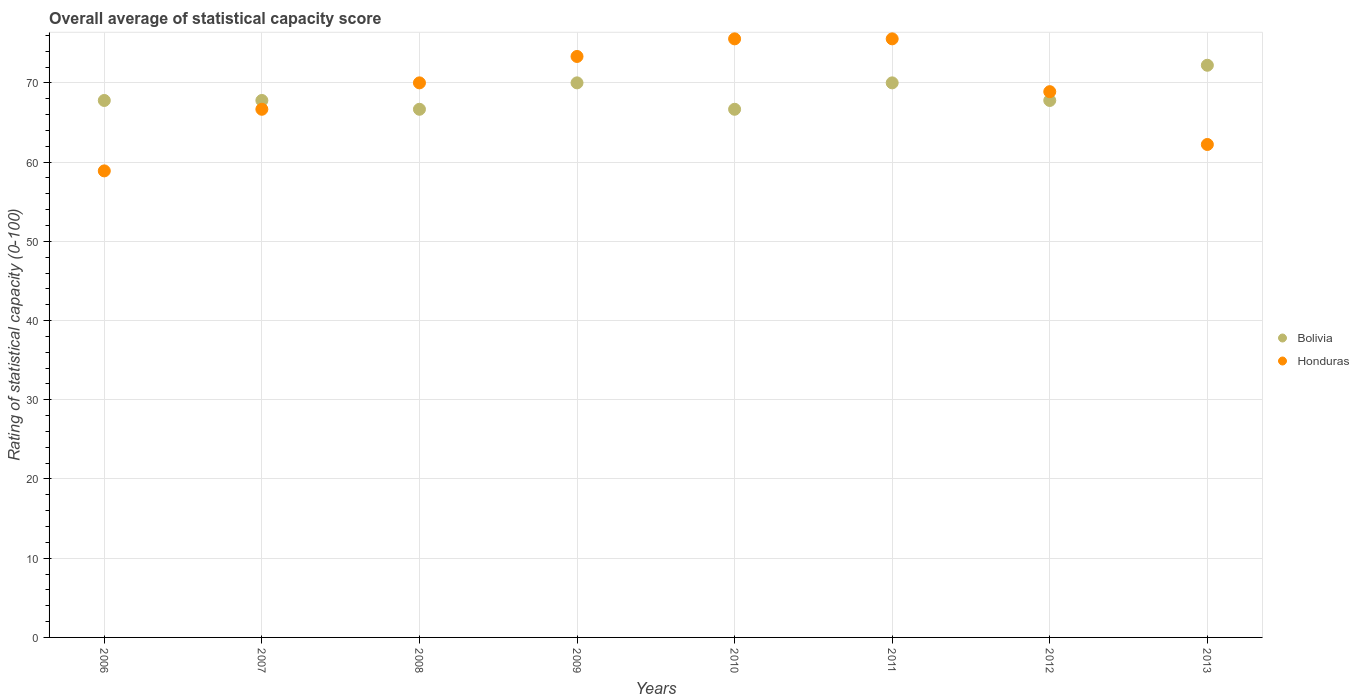How many different coloured dotlines are there?
Make the answer very short. 2. What is the rating of statistical capacity in Bolivia in 2012?
Your answer should be compact. 67.78. Across all years, what is the maximum rating of statistical capacity in Honduras?
Your response must be concise. 75.56. Across all years, what is the minimum rating of statistical capacity in Bolivia?
Make the answer very short. 66.67. What is the total rating of statistical capacity in Bolivia in the graph?
Provide a short and direct response. 548.89. What is the difference between the rating of statistical capacity in Bolivia in 2006 and that in 2010?
Offer a terse response. 1.11. What is the difference between the rating of statistical capacity in Honduras in 2006 and the rating of statistical capacity in Bolivia in 2013?
Your response must be concise. -13.33. What is the average rating of statistical capacity in Honduras per year?
Offer a terse response. 68.89. In the year 2011, what is the difference between the rating of statistical capacity in Bolivia and rating of statistical capacity in Honduras?
Keep it short and to the point. -5.56. In how many years, is the rating of statistical capacity in Bolivia greater than 34?
Give a very brief answer. 8. What is the ratio of the rating of statistical capacity in Bolivia in 2007 to that in 2010?
Your answer should be very brief. 1.02. Is the rating of statistical capacity in Honduras in 2010 less than that in 2013?
Ensure brevity in your answer.  No. What is the difference between the highest and the lowest rating of statistical capacity in Honduras?
Offer a very short reply. 16.67. Is the sum of the rating of statistical capacity in Bolivia in 2008 and 2013 greater than the maximum rating of statistical capacity in Honduras across all years?
Give a very brief answer. Yes. Does the rating of statistical capacity in Bolivia monotonically increase over the years?
Provide a succinct answer. No. Is the rating of statistical capacity in Bolivia strictly greater than the rating of statistical capacity in Honduras over the years?
Provide a succinct answer. No. What is the difference between two consecutive major ticks on the Y-axis?
Your answer should be compact. 10. How are the legend labels stacked?
Provide a succinct answer. Vertical. What is the title of the graph?
Give a very brief answer. Overall average of statistical capacity score. Does "Myanmar" appear as one of the legend labels in the graph?
Your answer should be very brief. No. What is the label or title of the Y-axis?
Your response must be concise. Rating of statistical capacity (0-100). What is the Rating of statistical capacity (0-100) in Bolivia in 2006?
Your answer should be compact. 67.78. What is the Rating of statistical capacity (0-100) in Honduras in 2006?
Give a very brief answer. 58.89. What is the Rating of statistical capacity (0-100) of Bolivia in 2007?
Provide a succinct answer. 67.78. What is the Rating of statistical capacity (0-100) in Honduras in 2007?
Provide a succinct answer. 66.67. What is the Rating of statistical capacity (0-100) in Bolivia in 2008?
Your response must be concise. 66.67. What is the Rating of statistical capacity (0-100) in Honduras in 2008?
Make the answer very short. 70. What is the Rating of statistical capacity (0-100) of Bolivia in 2009?
Ensure brevity in your answer.  70. What is the Rating of statistical capacity (0-100) of Honduras in 2009?
Keep it short and to the point. 73.33. What is the Rating of statistical capacity (0-100) in Bolivia in 2010?
Your answer should be very brief. 66.67. What is the Rating of statistical capacity (0-100) of Honduras in 2010?
Your response must be concise. 75.56. What is the Rating of statistical capacity (0-100) of Bolivia in 2011?
Keep it short and to the point. 70. What is the Rating of statistical capacity (0-100) of Honduras in 2011?
Your answer should be very brief. 75.56. What is the Rating of statistical capacity (0-100) in Bolivia in 2012?
Keep it short and to the point. 67.78. What is the Rating of statistical capacity (0-100) in Honduras in 2012?
Offer a very short reply. 68.89. What is the Rating of statistical capacity (0-100) of Bolivia in 2013?
Offer a very short reply. 72.22. What is the Rating of statistical capacity (0-100) in Honduras in 2013?
Ensure brevity in your answer.  62.22. Across all years, what is the maximum Rating of statistical capacity (0-100) in Bolivia?
Provide a succinct answer. 72.22. Across all years, what is the maximum Rating of statistical capacity (0-100) in Honduras?
Provide a short and direct response. 75.56. Across all years, what is the minimum Rating of statistical capacity (0-100) in Bolivia?
Ensure brevity in your answer.  66.67. Across all years, what is the minimum Rating of statistical capacity (0-100) in Honduras?
Offer a very short reply. 58.89. What is the total Rating of statistical capacity (0-100) of Bolivia in the graph?
Ensure brevity in your answer.  548.89. What is the total Rating of statistical capacity (0-100) of Honduras in the graph?
Offer a very short reply. 551.11. What is the difference between the Rating of statistical capacity (0-100) in Bolivia in 2006 and that in 2007?
Offer a terse response. 0. What is the difference between the Rating of statistical capacity (0-100) in Honduras in 2006 and that in 2007?
Offer a terse response. -7.78. What is the difference between the Rating of statistical capacity (0-100) of Bolivia in 2006 and that in 2008?
Your answer should be compact. 1.11. What is the difference between the Rating of statistical capacity (0-100) in Honduras in 2006 and that in 2008?
Provide a short and direct response. -11.11. What is the difference between the Rating of statistical capacity (0-100) in Bolivia in 2006 and that in 2009?
Give a very brief answer. -2.22. What is the difference between the Rating of statistical capacity (0-100) in Honduras in 2006 and that in 2009?
Your answer should be compact. -14.44. What is the difference between the Rating of statistical capacity (0-100) of Bolivia in 2006 and that in 2010?
Provide a succinct answer. 1.11. What is the difference between the Rating of statistical capacity (0-100) of Honduras in 2006 and that in 2010?
Make the answer very short. -16.67. What is the difference between the Rating of statistical capacity (0-100) in Bolivia in 2006 and that in 2011?
Keep it short and to the point. -2.22. What is the difference between the Rating of statistical capacity (0-100) in Honduras in 2006 and that in 2011?
Make the answer very short. -16.67. What is the difference between the Rating of statistical capacity (0-100) of Bolivia in 2006 and that in 2012?
Keep it short and to the point. 0. What is the difference between the Rating of statistical capacity (0-100) in Bolivia in 2006 and that in 2013?
Offer a terse response. -4.44. What is the difference between the Rating of statistical capacity (0-100) of Honduras in 2006 and that in 2013?
Keep it short and to the point. -3.33. What is the difference between the Rating of statistical capacity (0-100) in Bolivia in 2007 and that in 2009?
Offer a terse response. -2.22. What is the difference between the Rating of statistical capacity (0-100) of Honduras in 2007 and that in 2009?
Keep it short and to the point. -6.67. What is the difference between the Rating of statistical capacity (0-100) in Honduras in 2007 and that in 2010?
Make the answer very short. -8.89. What is the difference between the Rating of statistical capacity (0-100) of Bolivia in 2007 and that in 2011?
Offer a terse response. -2.22. What is the difference between the Rating of statistical capacity (0-100) in Honduras in 2007 and that in 2011?
Give a very brief answer. -8.89. What is the difference between the Rating of statistical capacity (0-100) of Honduras in 2007 and that in 2012?
Your answer should be very brief. -2.22. What is the difference between the Rating of statistical capacity (0-100) in Bolivia in 2007 and that in 2013?
Make the answer very short. -4.44. What is the difference between the Rating of statistical capacity (0-100) in Honduras in 2007 and that in 2013?
Offer a terse response. 4.44. What is the difference between the Rating of statistical capacity (0-100) in Honduras in 2008 and that in 2009?
Give a very brief answer. -3.33. What is the difference between the Rating of statistical capacity (0-100) of Honduras in 2008 and that in 2010?
Your response must be concise. -5.56. What is the difference between the Rating of statistical capacity (0-100) in Bolivia in 2008 and that in 2011?
Keep it short and to the point. -3.33. What is the difference between the Rating of statistical capacity (0-100) of Honduras in 2008 and that in 2011?
Provide a short and direct response. -5.56. What is the difference between the Rating of statistical capacity (0-100) of Bolivia in 2008 and that in 2012?
Your answer should be very brief. -1.11. What is the difference between the Rating of statistical capacity (0-100) of Honduras in 2008 and that in 2012?
Offer a very short reply. 1.11. What is the difference between the Rating of statistical capacity (0-100) in Bolivia in 2008 and that in 2013?
Your response must be concise. -5.56. What is the difference between the Rating of statistical capacity (0-100) in Honduras in 2008 and that in 2013?
Your response must be concise. 7.78. What is the difference between the Rating of statistical capacity (0-100) in Honduras in 2009 and that in 2010?
Make the answer very short. -2.22. What is the difference between the Rating of statistical capacity (0-100) in Bolivia in 2009 and that in 2011?
Give a very brief answer. 0. What is the difference between the Rating of statistical capacity (0-100) in Honduras in 2009 and that in 2011?
Offer a terse response. -2.22. What is the difference between the Rating of statistical capacity (0-100) of Bolivia in 2009 and that in 2012?
Ensure brevity in your answer.  2.22. What is the difference between the Rating of statistical capacity (0-100) of Honduras in 2009 and that in 2012?
Keep it short and to the point. 4.44. What is the difference between the Rating of statistical capacity (0-100) in Bolivia in 2009 and that in 2013?
Your answer should be very brief. -2.22. What is the difference between the Rating of statistical capacity (0-100) of Honduras in 2009 and that in 2013?
Provide a short and direct response. 11.11. What is the difference between the Rating of statistical capacity (0-100) in Bolivia in 2010 and that in 2011?
Offer a terse response. -3.33. What is the difference between the Rating of statistical capacity (0-100) of Bolivia in 2010 and that in 2012?
Your response must be concise. -1.11. What is the difference between the Rating of statistical capacity (0-100) of Bolivia in 2010 and that in 2013?
Your response must be concise. -5.56. What is the difference between the Rating of statistical capacity (0-100) of Honduras in 2010 and that in 2013?
Your answer should be compact. 13.33. What is the difference between the Rating of statistical capacity (0-100) of Bolivia in 2011 and that in 2012?
Make the answer very short. 2.22. What is the difference between the Rating of statistical capacity (0-100) in Honduras in 2011 and that in 2012?
Offer a very short reply. 6.67. What is the difference between the Rating of statistical capacity (0-100) of Bolivia in 2011 and that in 2013?
Give a very brief answer. -2.22. What is the difference between the Rating of statistical capacity (0-100) in Honduras in 2011 and that in 2013?
Make the answer very short. 13.33. What is the difference between the Rating of statistical capacity (0-100) in Bolivia in 2012 and that in 2013?
Keep it short and to the point. -4.44. What is the difference between the Rating of statistical capacity (0-100) of Honduras in 2012 and that in 2013?
Offer a terse response. 6.67. What is the difference between the Rating of statistical capacity (0-100) of Bolivia in 2006 and the Rating of statistical capacity (0-100) of Honduras in 2008?
Provide a short and direct response. -2.22. What is the difference between the Rating of statistical capacity (0-100) of Bolivia in 2006 and the Rating of statistical capacity (0-100) of Honduras in 2009?
Offer a terse response. -5.56. What is the difference between the Rating of statistical capacity (0-100) of Bolivia in 2006 and the Rating of statistical capacity (0-100) of Honduras in 2010?
Your answer should be compact. -7.78. What is the difference between the Rating of statistical capacity (0-100) in Bolivia in 2006 and the Rating of statistical capacity (0-100) in Honduras in 2011?
Ensure brevity in your answer.  -7.78. What is the difference between the Rating of statistical capacity (0-100) in Bolivia in 2006 and the Rating of statistical capacity (0-100) in Honduras in 2012?
Your answer should be very brief. -1.11. What is the difference between the Rating of statistical capacity (0-100) of Bolivia in 2006 and the Rating of statistical capacity (0-100) of Honduras in 2013?
Keep it short and to the point. 5.56. What is the difference between the Rating of statistical capacity (0-100) in Bolivia in 2007 and the Rating of statistical capacity (0-100) in Honduras in 2008?
Offer a very short reply. -2.22. What is the difference between the Rating of statistical capacity (0-100) of Bolivia in 2007 and the Rating of statistical capacity (0-100) of Honduras in 2009?
Your answer should be very brief. -5.56. What is the difference between the Rating of statistical capacity (0-100) of Bolivia in 2007 and the Rating of statistical capacity (0-100) of Honduras in 2010?
Offer a terse response. -7.78. What is the difference between the Rating of statistical capacity (0-100) of Bolivia in 2007 and the Rating of statistical capacity (0-100) of Honduras in 2011?
Give a very brief answer. -7.78. What is the difference between the Rating of statistical capacity (0-100) of Bolivia in 2007 and the Rating of statistical capacity (0-100) of Honduras in 2012?
Provide a short and direct response. -1.11. What is the difference between the Rating of statistical capacity (0-100) of Bolivia in 2007 and the Rating of statistical capacity (0-100) of Honduras in 2013?
Provide a short and direct response. 5.56. What is the difference between the Rating of statistical capacity (0-100) of Bolivia in 2008 and the Rating of statistical capacity (0-100) of Honduras in 2009?
Offer a terse response. -6.67. What is the difference between the Rating of statistical capacity (0-100) of Bolivia in 2008 and the Rating of statistical capacity (0-100) of Honduras in 2010?
Your answer should be compact. -8.89. What is the difference between the Rating of statistical capacity (0-100) in Bolivia in 2008 and the Rating of statistical capacity (0-100) in Honduras in 2011?
Offer a terse response. -8.89. What is the difference between the Rating of statistical capacity (0-100) in Bolivia in 2008 and the Rating of statistical capacity (0-100) in Honduras in 2012?
Offer a very short reply. -2.22. What is the difference between the Rating of statistical capacity (0-100) in Bolivia in 2008 and the Rating of statistical capacity (0-100) in Honduras in 2013?
Your answer should be compact. 4.44. What is the difference between the Rating of statistical capacity (0-100) of Bolivia in 2009 and the Rating of statistical capacity (0-100) of Honduras in 2010?
Offer a very short reply. -5.56. What is the difference between the Rating of statistical capacity (0-100) in Bolivia in 2009 and the Rating of statistical capacity (0-100) in Honduras in 2011?
Your answer should be very brief. -5.56. What is the difference between the Rating of statistical capacity (0-100) of Bolivia in 2009 and the Rating of statistical capacity (0-100) of Honduras in 2012?
Make the answer very short. 1.11. What is the difference between the Rating of statistical capacity (0-100) in Bolivia in 2009 and the Rating of statistical capacity (0-100) in Honduras in 2013?
Provide a short and direct response. 7.78. What is the difference between the Rating of statistical capacity (0-100) of Bolivia in 2010 and the Rating of statistical capacity (0-100) of Honduras in 2011?
Provide a succinct answer. -8.89. What is the difference between the Rating of statistical capacity (0-100) of Bolivia in 2010 and the Rating of statistical capacity (0-100) of Honduras in 2012?
Keep it short and to the point. -2.22. What is the difference between the Rating of statistical capacity (0-100) in Bolivia in 2010 and the Rating of statistical capacity (0-100) in Honduras in 2013?
Your answer should be very brief. 4.44. What is the difference between the Rating of statistical capacity (0-100) in Bolivia in 2011 and the Rating of statistical capacity (0-100) in Honduras in 2013?
Keep it short and to the point. 7.78. What is the difference between the Rating of statistical capacity (0-100) of Bolivia in 2012 and the Rating of statistical capacity (0-100) of Honduras in 2013?
Make the answer very short. 5.56. What is the average Rating of statistical capacity (0-100) in Bolivia per year?
Make the answer very short. 68.61. What is the average Rating of statistical capacity (0-100) in Honduras per year?
Ensure brevity in your answer.  68.89. In the year 2006, what is the difference between the Rating of statistical capacity (0-100) of Bolivia and Rating of statistical capacity (0-100) of Honduras?
Your response must be concise. 8.89. In the year 2007, what is the difference between the Rating of statistical capacity (0-100) of Bolivia and Rating of statistical capacity (0-100) of Honduras?
Give a very brief answer. 1.11. In the year 2008, what is the difference between the Rating of statistical capacity (0-100) in Bolivia and Rating of statistical capacity (0-100) in Honduras?
Give a very brief answer. -3.33. In the year 2010, what is the difference between the Rating of statistical capacity (0-100) in Bolivia and Rating of statistical capacity (0-100) in Honduras?
Make the answer very short. -8.89. In the year 2011, what is the difference between the Rating of statistical capacity (0-100) in Bolivia and Rating of statistical capacity (0-100) in Honduras?
Keep it short and to the point. -5.56. In the year 2012, what is the difference between the Rating of statistical capacity (0-100) of Bolivia and Rating of statistical capacity (0-100) of Honduras?
Give a very brief answer. -1.11. In the year 2013, what is the difference between the Rating of statistical capacity (0-100) in Bolivia and Rating of statistical capacity (0-100) in Honduras?
Ensure brevity in your answer.  10. What is the ratio of the Rating of statistical capacity (0-100) in Bolivia in 2006 to that in 2007?
Make the answer very short. 1. What is the ratio of the Rating of statistical capacity (0-100) in Honduras in 2006 to that in 2007?
Ensure brevity in your answer.  0.88. What is the ratio of the Rating of statistical capacity (0-100) in Bolivia in 2006 to that in 2008?
Make the answer very short. 1.02. What is the ratio of the Rating of statistical capacity (0-100) of Honduras in 2006 to that in 2008?
Keep it short and to the point. 0.84. What is the ratio of the Rating of statistical capacity (0-100) in Bolivia in 2006 to that in 2009?
Offer a very short reply. 0.97. What is the ratio of the Rating of statistical capacity (0-100) of Honduras in 2006 to that in 2009?
Your answer should be compact. 0.8. What is the ratio of the Rating of statistical capacity (0-100) of Bolivia in 2006 to that in 2010?
Ensure brevity in your answer.  1.02. What is the ratio of the Rating of statistical capacity (0-100) of Honduras in 2006 to that in 2010?
Keep it short and to the point. 0.78. What is the ratio of the Rating of statistical capacity (0-100) in Bolivia in 2006 to that in 2011?
Your answer should be compact. 0.97. What is the ratio of the Rating of statistical capacity (0-100) in Honduras in 2006 to that in 2011?
Offer a terse response. 0.78. What is the ratio of the Rating of statistical capacity (0-100) of Honduras in 2006 to that in 2012?
Provide a short and direct response. 0.85. What is the ratio of the Rating of statistical capacity (0-100) in Bolivia in 2006 to that in 2013?
Your answer should be compact. 0.94. What is the ratio of the Rating of statistical capacity (0-100) in Honduras in 2006 to that in 2013?
Keep it short and to the point. 0.95. What is the ratio of the Rating of statistical capacity (0-100) of Bolivia in 2007 to that in 2008?
Your answer should be compact. 1.02. What is the ratio of the Rating of statistical capacity (0-100) of Bolivia in 2007 to that in 2009?
Keep it short and to the point. 0.97. What is the ratio of the Rating of statistical capacity (0-100) of Honduras in 2007 to that in 2009?
Provide a succinct answer. 0.91. What is the ratio of the Rating of statistical capacity (0-100) of Bolivia in 2007 to that in 2010?
Your answer should be very brief. 1.02. What is the ratio of the Rating of statistical capacity (0-100) in Honduras in 2007 to that in 2010?
Ensure brevity in your answer.  0.88. What is the ratio of the Rating of statistical capacity (0-100) of Bolivia in 2007 to that in 2011?
Provide a short and direct response. 0.97. What is the ratio of the Rating of statistical capacity (0-100) of Honduras in 2007 to that in 2011?
Provide a short and direct response. 0.88. What is the ratio of the Rating of statistical capacity (0-100) of Bolivia in 2007 to that in 2012?
Your answer should be compact. 1. What is the ratio of the Rating of statistical capacity (0-100) in Honduras in 2007 to that in 2012?
Offer a very short reply. 0.97. What is the ratio of the Rating of statistical capacity (0-100) in Bolivia in 2007 to that in 2013?
Your answer should be compact. 0.94. What is the ratio of the Rating of statistical capacity (0-100) of Honduras in 2007 to that in 2013?
Provide a succinct answer. 1.07. What is the ratio of the Rating of statistical capacity (0-100) in Bolivia in 2008 to that in 2009?
Provide a short and direct response. 0.95. What is the ratio of the Rating of statistical capacity (0-100) of Honduras in 2008 to that in 2009?
Your answer should be compact. 0.95. What is the ratio of the Rating of statistical capacity (0-100) in Bolivia in 2008 to that in 2010?
Your response must be concise. 1. What is the ratio of the Rating of statistical capacity (0-100) of Honduras in 2008 to that in 2010?
Make the answer very short. 0.93. What is the ratio of the Rating of statistical capacity (0-100) in Honduras in 2008 to that in 2011?
Keep it short and to the point. 0.93. What is the ratio of the Rating of statistical capacity (0-100) in Bolivia in 2008 to that in 2012?
Your answer should be compact. 0.98. What is the ratio of the Rating of statistical capacity (0-100) of Honduras in 2008 to that in 2012?
Ensure brevity in your answer.  1.02. What is the ratio of the Rating of statistical capacity (0-100) of Honduras in 2009 to that in 2010?
Give a very brief answer. 0.97. What is the ratio of the Rating of statistical capacity (0-100) of Bolivia in 2009 to that in 2011?
Ensure brevity in your answer.  1. What is the ratio of the Rating of statistical capacity (0-100) in Honduras in 2009 to that in 2011?
Your answer should be compact. 0.97. What is the ratio of the Rating of statistical capacity (0-100) of Bolivia in 2009 to that in 2012?
Offer a very short reply. 1.03. What is the ratio of the Rating of statistical capacity (0-100) in Honduras in 2009 to that in 2012?
Provide a succinct answer. 1.06. What is the ratio of the Rating of statistical capacity (0-100) of Bolivia in 2009 to that in 2013?
Ensure brevity in your answer.  0.97. What is the ratio of the Rating of statistical capacity (0-100) of Honduras in 2009 to that in 2013?
Make the answer very short. 1.18. What is the ratio of the Rating of statistical capacity (0-100) of Bolivia in 2010 to that in 2011?
Keep it short and to the point. 0.95. What is the ratio of the Rating of statistical capacity (0-100) of Bolivia in 2010 to that in 2012?
Provide a short and direct response. 0.98. What is the ratio of the Rating of statistical capacity (0-100) in Honduras in 2010 to that in 2012?
Your answer should be very brief. 1.1. What is the ratio of the Rating of statistical capacity (0-100) of Honduras in 2010 to that in 2013?
Your answer should be compact. 1.21. What is the ratio of the Rating of statistical capacity (0-100) in Bolivia in 2011 to that in 2012?
Provide a succinct answer. 1.03. What is the ratio of the Rating of statistical capacity (0-100) in Honduras in 2011 to that in 2012?
Your answer should be compact. 1.1. What is the ratio of the Rating of statistical capacity (0-100) in Bolivia in 2011 to that in 2013?
Make the answer very short. 0.97. What is the ratio of the Rating of statistical capacity (0-100) of Honduras in 2011 to that in 2013?
Your response must be concise. 1.21. What is the ratio of the Rating of statistical capacity (0-100) in Bolivia in 2012 to that in 2013?
Offer a very short reply. 0.94. What is the ratio of the Rating of statistical capacity (0-100) in Honduras in 2012 to that in 2013?
Provide a succinct answer. 1.11. What is the difference between the highest and the second highest Rating of statistical capacity (0-100) of Bolivia?
Offer a very short reply. 2.22. What is the difference between the highest and the second highest Rating of statistical capacity (0-100) in Honduras?
Keep it short and to the point. 0. What is the difference between the highest and the lowest Rating of statistical capacity (0-100) in Bolivia?
Offer a terse response. 5.56. What is the difference between the highest and the lowest Rating of statistical capacity (0-100) in Honduras?
Your answer should be very brief. 16.67. 